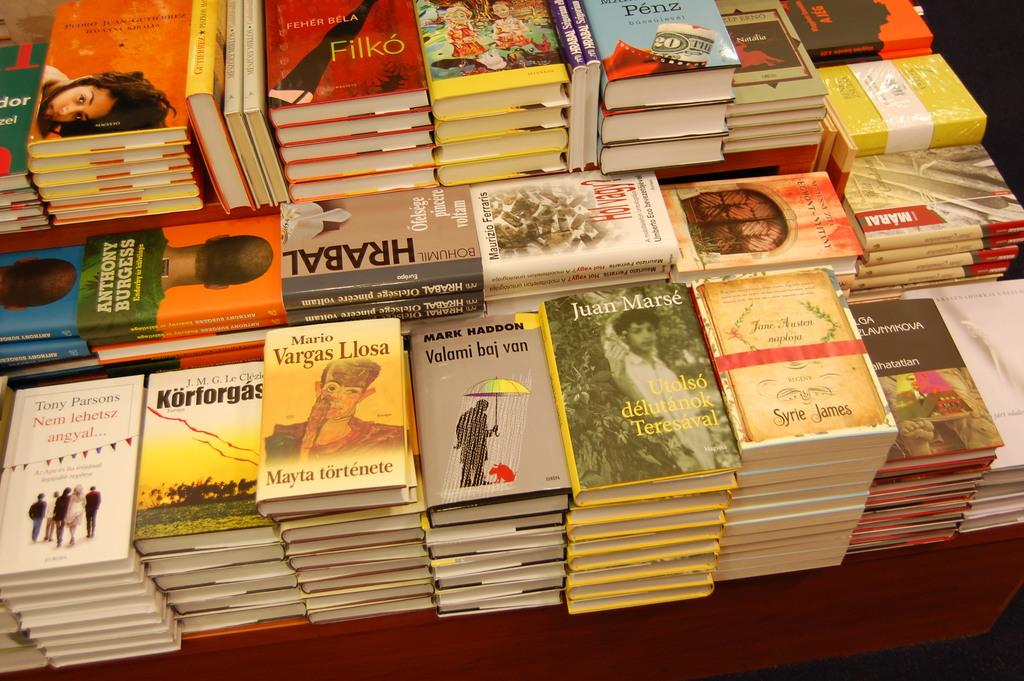Provide a one-sentence caption for the provided image. Multiple stacks of books on a table, including one by Vargas Llosa. 